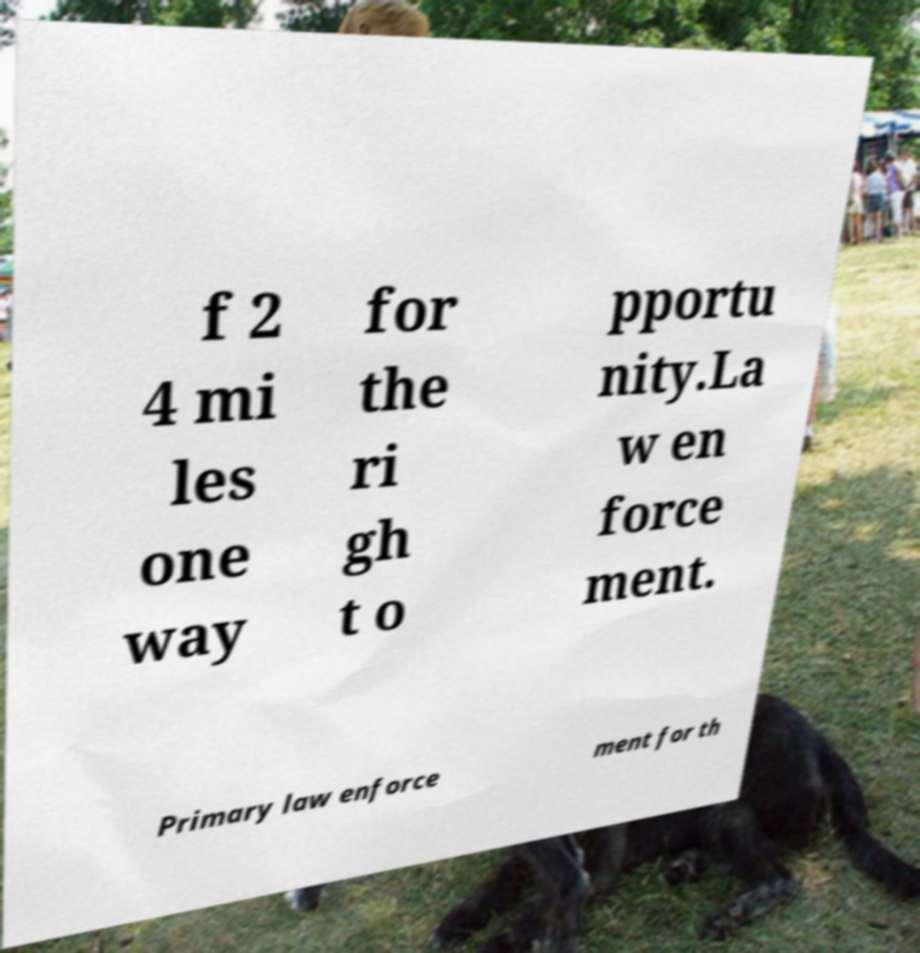Please read and relay the text visible in this image. What does it say? f 2 4 mi les one way for the ri gh t o pportu nity.La w en force ment. Primary law enforce ment for th 